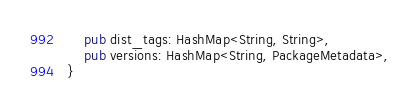<code> <loc_0><loc_0><loc_500><loc_500><_Rust_>    pub dist_tags: HashMap<String, String>,
    pub versions: HashMap<String, PackageMetadata>,
}
</code> 